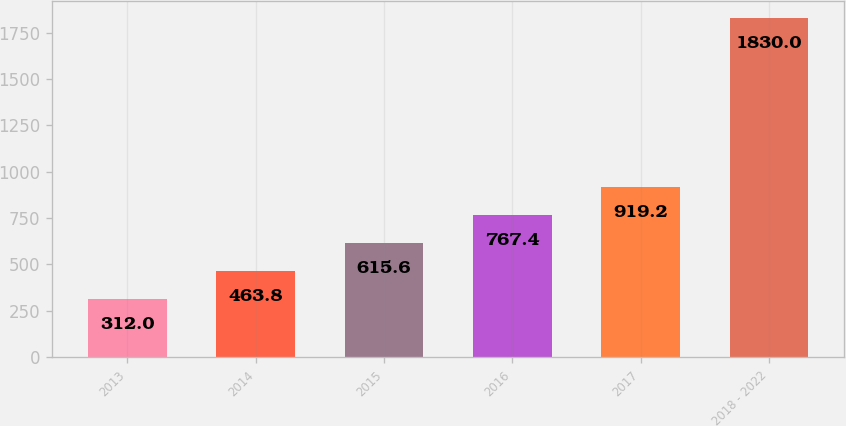Convert chart. <chart><loc_0><loc_0><loc_500><loc_500><bar_chart><fcel>2013<fcel>2014<fcel>2015<fcel>2016<fcel>2017<fcel>2018 - 2022<nl><fcel>312<fcel>463.8<fcel>615.6<fcel>767.4<fcel>919.2<fcel>1830<nl></chart> 